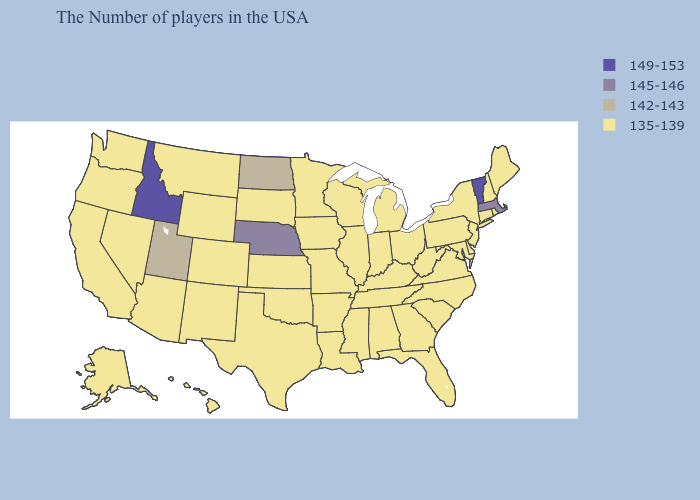Name the states that have a value in the range 142-143?
Quick response, please. North Dakota, Utah. Does Utah have a higher value than Florida?
Give a very brief answer. Yes. Does Ohio have the lowest value in the MidWest?
Give a very brief answer. Yes. Name the states that have a value in the range 142-143?
Keep it brief. North Dakota, Utah. Name the states that have a value in the range 145-146?
Give a very brief answer. Massachusetts, Nebraska. Does North Dakota have the lowest value in the USA?
Quick response, please. No. Name the states that have a value in the range 142-143?
Give a very brief answer. North Dakota, Utah. Name the states that have a value in the range 142-143?
Quick response, please. North Dakota, Utah. What is the highest value in the USA?
Write a very short answer. 149-153. What is the value of West Virginia?
Keep it brief. 135-139. Which states have the lowest value in the USA?
Keep it brief. Maine, Rhode Island, New Hampshire, Connecticut, New York, New Jersey, Delaware, Maryland, Pennsylvania, Virginia, North Carolina, South Carolina, West Virginia, Ohio, Florida, Georgia, Michigan, Kentucky, Indiana, Alabama, Tennessee, Wisconsin, Illinois, Mississippi, Louisiana, Missouri, Arkansas, Minnesota, Iowa, Kansas, Oklahoma, Texas, South Dakota, Wyoming, Colorado, New Mexico, Montana, Arizona, Nevada, California, Washington, Oregon, Alaska, Hawaii. What is the value of Louisiana?
Write a very short answer. 135-139. What is the value of New Hampshire?
Answer briefly. 135-139. What is the value of Louisiana?
Give a very brief answer. 135-139. Does Utah have the lowest value in the USA?
Answer briefly. No. 